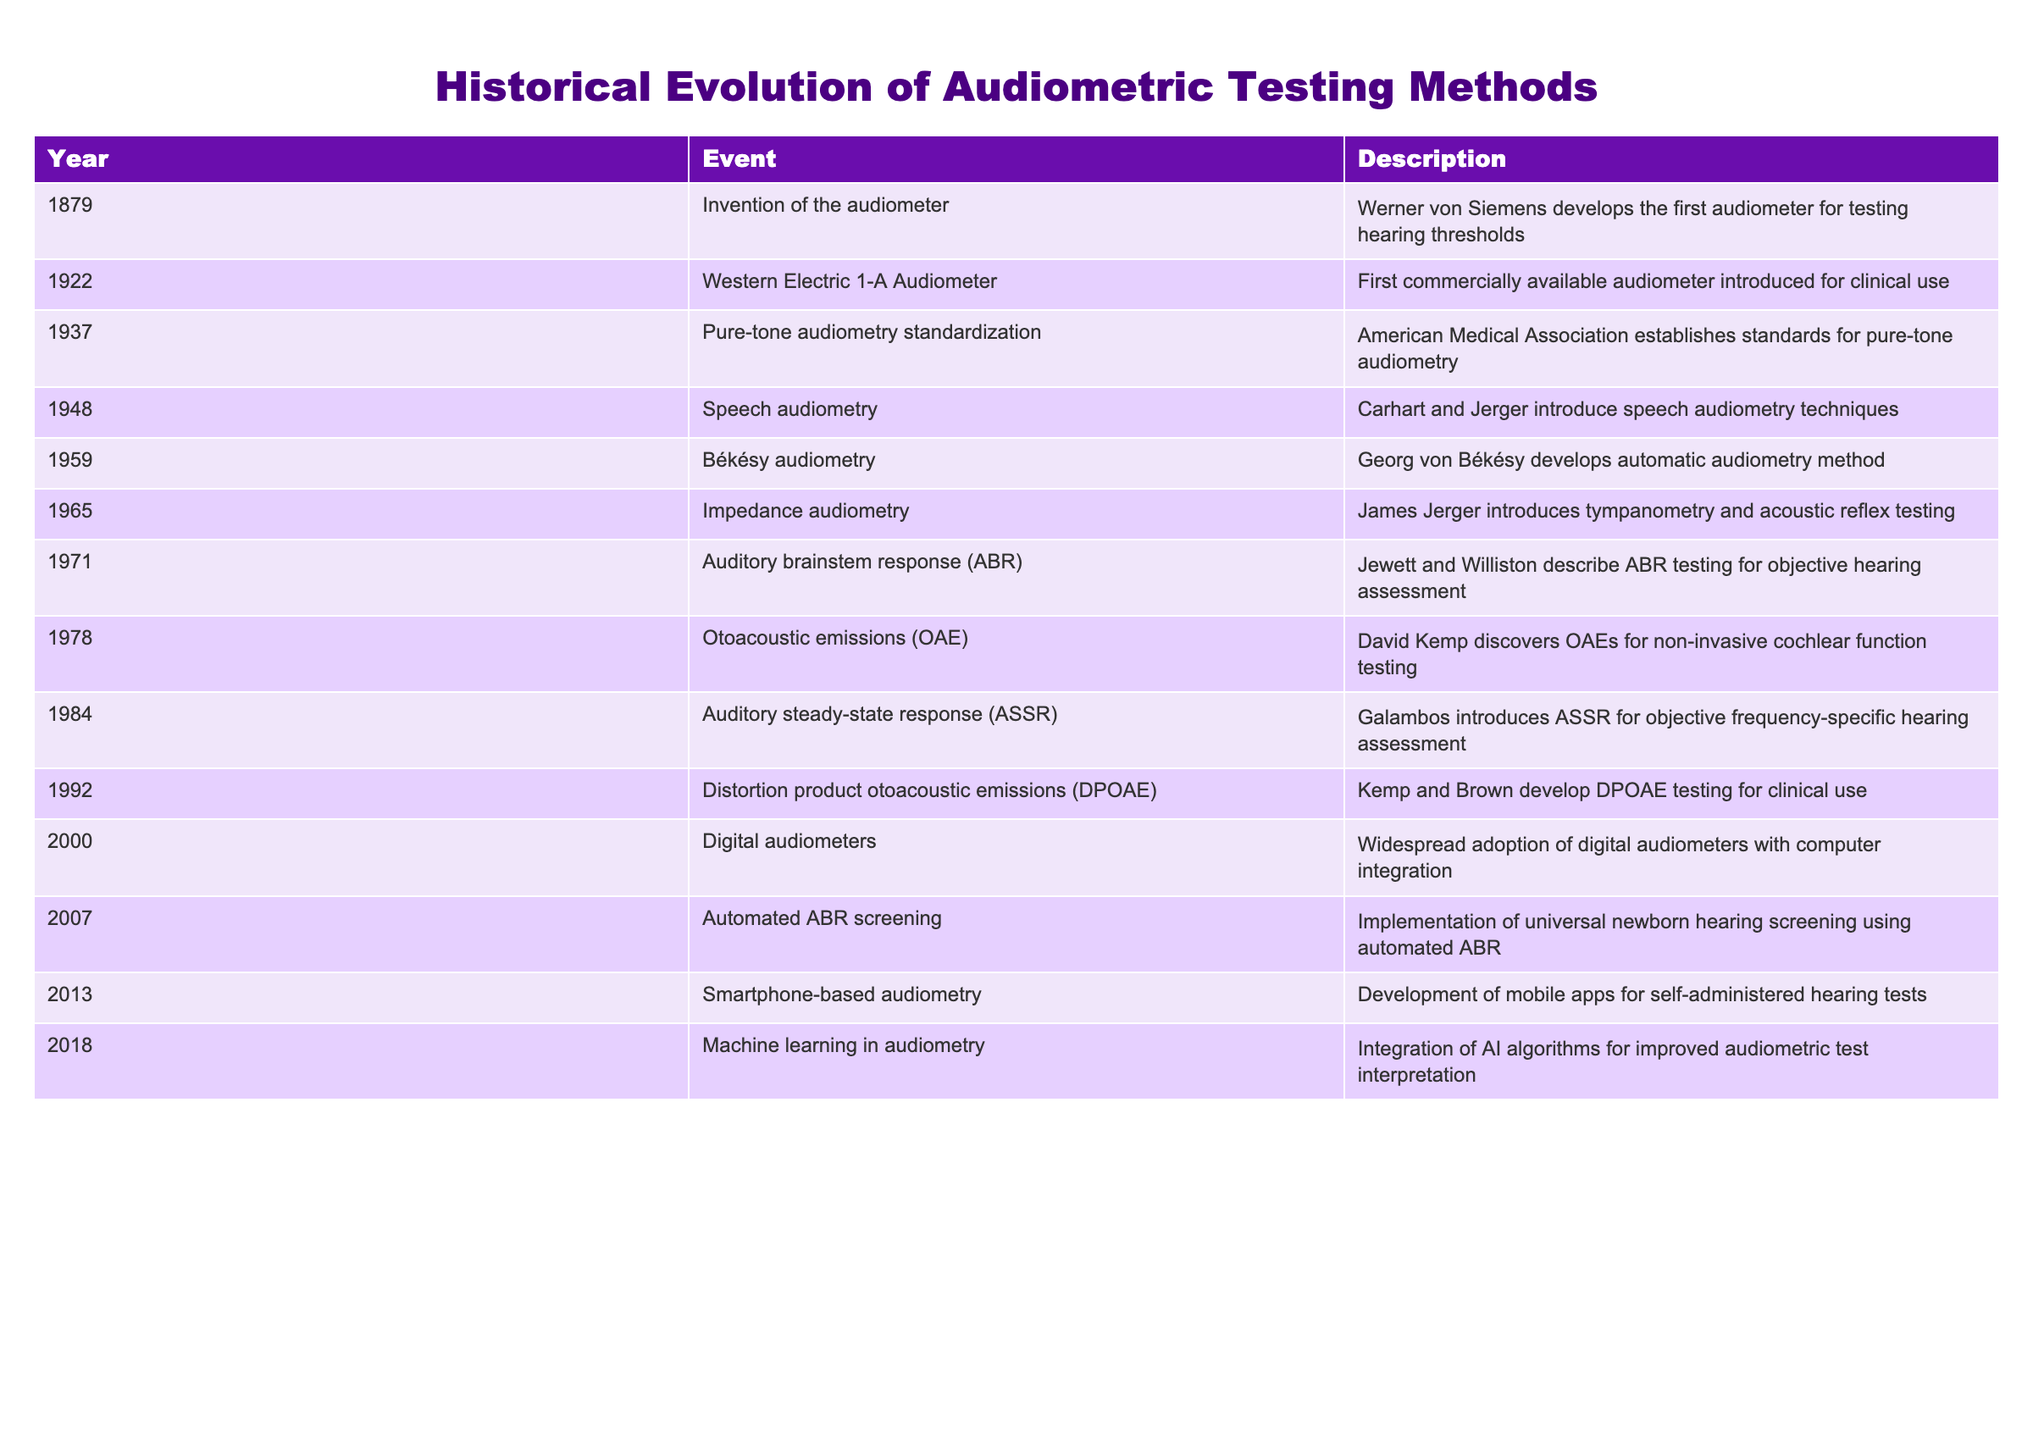What year was the first commercially available audiometer introduced? The table shows that the first commercially available audiometer was introduced in 1922.
Answer: 1922 Who developed the automatic audiometry method? According to the table, Georg von Békésy developed the automatic audiometry method in 1959.
Answer: Georg von Békésy Was impedance audiometry introduced before or after auditory brainstem response testing? The table indicates that impedance audiometry was introduced in 1965 and auditory brainstem response testing in 1971, so impedance audiometry was introduced before ABR testing.
Answer: Before What is the interval in years between the introduction of speech audiometry and the discovery of otoacoustic emissions? Speech audiometry was introduced in 1948 and otoacoustic emissions were discovered in 1978. The interval is 30 years (1978 - 1948 = 30).
Answer: 30 years Was the introduction of digital audiometers in the year 2000 significant for the history of audiometric testing? Yes, the table indicates widespread adoption of digital audiometers occurred in 2000, marking a significant technological advancement in audiometric testing.
Answer: Yes What are the two audiometric testing methods that were discovered in the 1980s? According to the table, the two methods introduced in the 1980s were auditory steady-state response in 1984 and distortion product otoacoustic emissions in 1992, which is not in the 1980s. The only method in the 1980s is auditory steady-state response in 1984.
Answer: Auditory steady-state response What was the main contribution of David Kemp in 1978? The table states that in 1978, David Kemp discovered otoacoustic emissions for non-invasive cochlear function testing.
Answer: Otoacoustic emissions Calculate the total number of significant events related to audiometric testing from 1879 to 2018. The table lists 13 significant events from 1879 to 2018. Therefore, the total number of events is 13.
Answer: 13 In which year was smartphone-based audiometry developed? The table shows that smartphone-based audiometry was developed in 2013.
Answer: 2013 